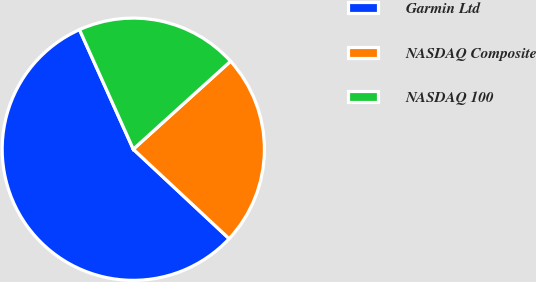<chart> <loc_0><loc_0><loc_500><loc_500><pie_chart><fcel>Garmin Ltd<fcel>NASDAQ Composite<fcel>NASDAQ 100<nl><fcel>56.32%<fcel>23.66%<fcel>20.03%<nl></chart> 